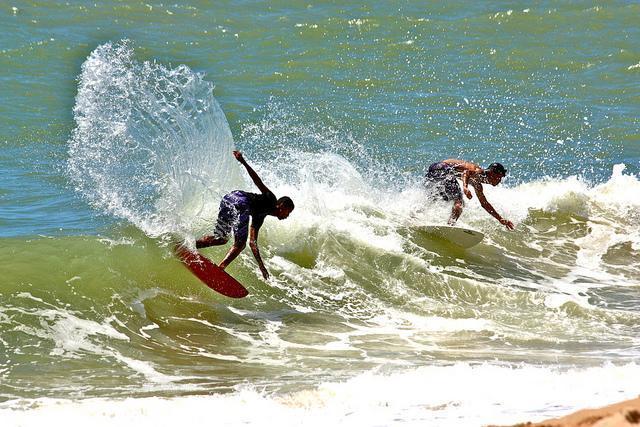How many surfers?
Give a very brief answer. 2. How many people can be seen?
Give a very brief answer. 2. 